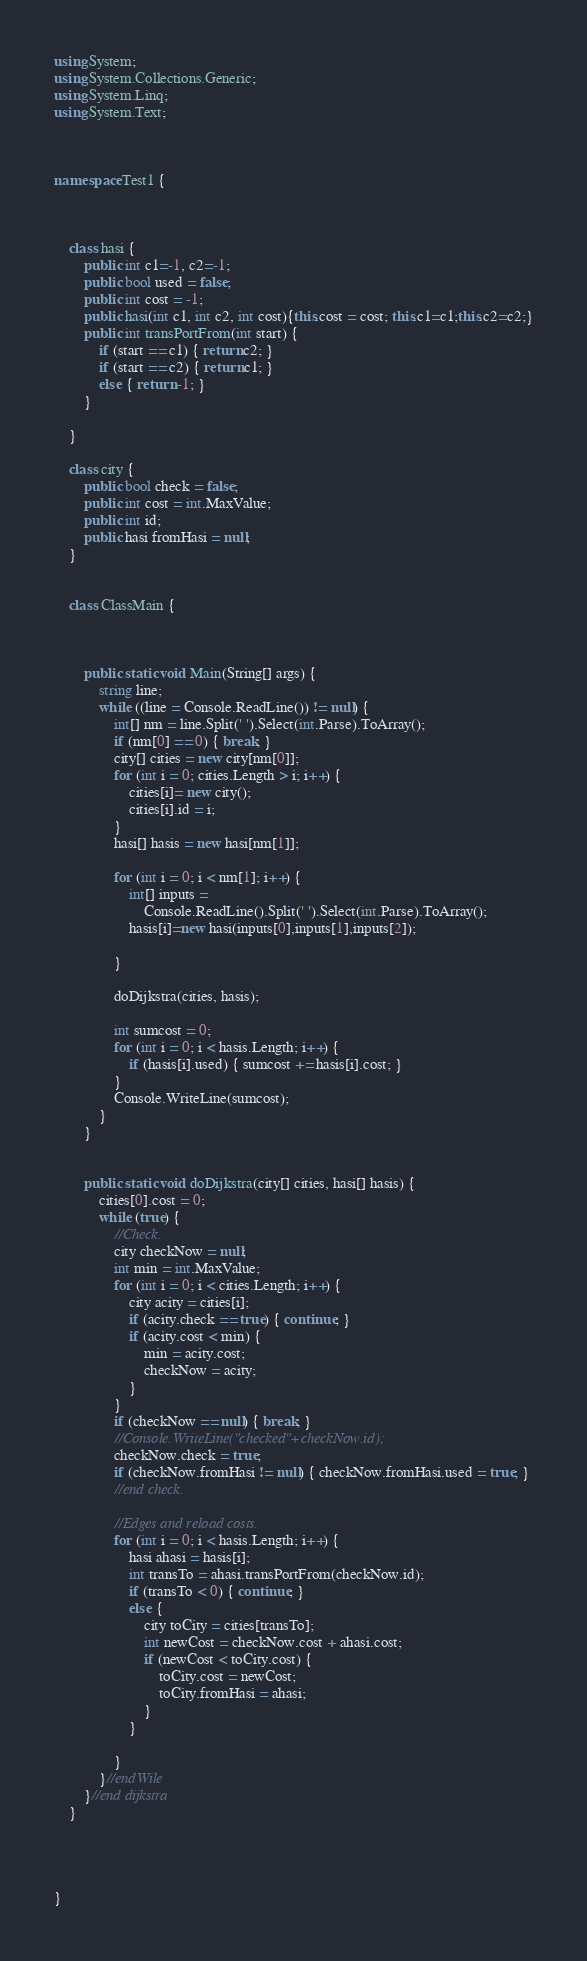<code> <loc_0><loc_0><loc_500><loc_500><_C#_>using System;
using System.Collections.Generic;
using System.Linq;
using System.Text;



namespace Test1 {



    class hasi {
        public int c1=-1, c2=-1;
        public bool used = false;
        public int cost = -1;
        public hasi(int c1, int c2, int cost){this.cost = cost; this.c1=c1;this.c2=c2;}
        public int transPortFrom(int start) {
            if (start == c1) { return c2; }
            if (start == c2) { return c1; }
            else { return -1; }
        }

    }

    class city {
        public bool check = false;
        public int cost = int.MaxValue;
        public int id;
        public hasi fromHasi = null;
    }


    class ClassMain {

       

        public static void Main(String[] args) {
            string line;
            while ((line = Console.ReadLine()) != null) {
                int[] nm = line.Split(' ').Select(int.Parse).ToArray();
                if (nm[0] == 0) { break; }
                city[] cities = new city[nm[0]];
                for (int i = 0; cities.Length > i; i++) { 
                    cities[i]= new city();
                    cities[i].id = i; 
                }
                hasi[] hasis = new hasi[nm[1]];

                for (int i = 0; i < nm[1]; i++) {
                    int[] inputs =
                        Console.ReadLine().Split(' ').Select(int.Parse).ToArray();
                    hasis[i]=new hasi(inputs[0],inputs[1],inputs[2]);

                }

                doDijkstra(cities, hasis);

                int sumcost = 0;
                for (int i = 0; i < hasis.Length; i++) {
                    if (hasis[i].used) { sumcost += hasis[i].cost; }
                }
                Console.WriteLine(sumcost);
            }
        }


        public static void doDijkstra(city[] cities, hasi[] hasis) {
            cities[0].cost = 0;
            while (true) {
                //Check.
                city checkNow = null;
                int min = int.MaxValue;
                for (int i = 0; i < cities.Length; i++) {
                    city acity = cities[i];
                    if (acity.check == true) { continue; }
                    if (acity.cost < min) {
                        min = acity.cost;
                        checkNow = acity;
                    }
                }
                if (checkNow == null) { break; }
                //Console.WriteLine("checked"+checkNow.id);
                checkNow.check = true;
                if (checkNow.fromHasi != null) { checkNow.fromHasi.used = true; }
                //end check.

                //Edges and reload costs.
                for (int i = 0; i < hasis.Length; i++) {
                    hasi ahasi = hasis[i];
                    int transTo = ahasi.transPortFrom(checkNow.id);
                    if (transTo < 0) { continue; }
                    else {
                        city toCity = cities[transTo];
                        int newCost = checkNow.cost + ahasi.cost;
                        if (newCost < toCity.cost) {
                            toCity.cost = newCost;
                            toCity.fromHasi = ahasi;
                        }
                    }

                }
            }//endWile
        }//end dijkstra
    }



    
}</code> 